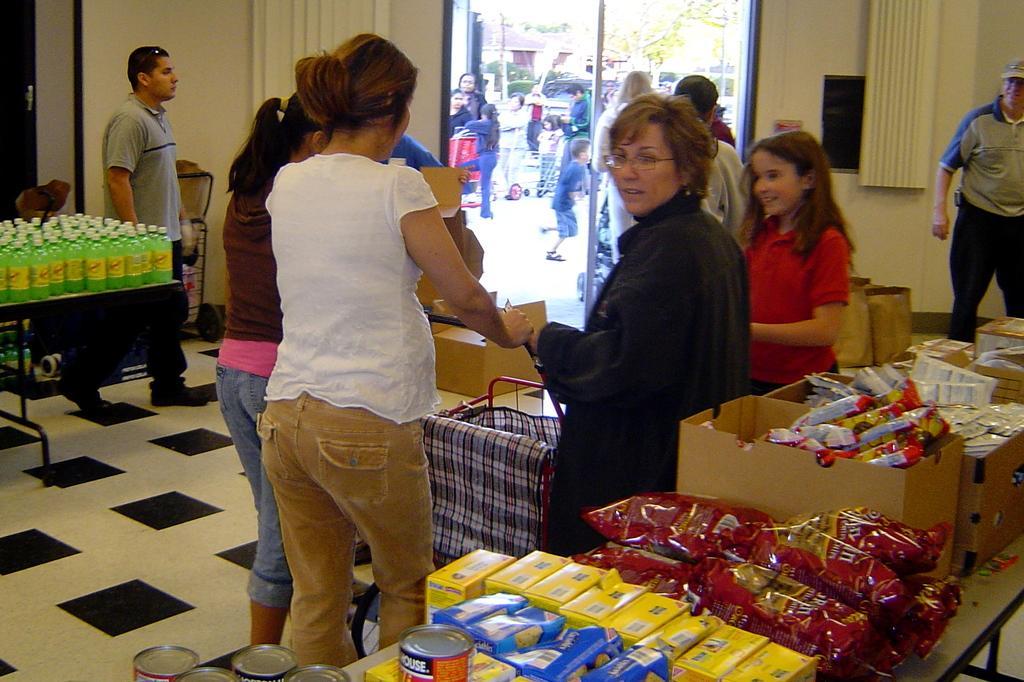Describe this image in one or two sentences. In this picture there is group of people on the right side of the image, by holding a trolley and there are grocery stock on the right and left side of the image and there is a door in the center of the image, it seems to be a marketplace. 